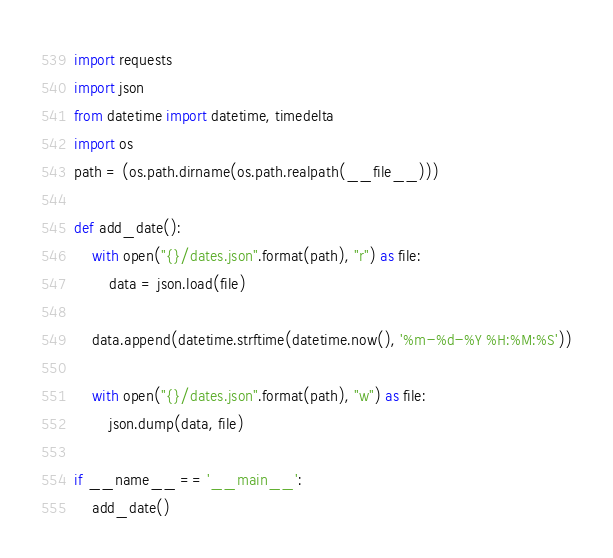<code> <loc_0><loc_0><loc_500><loc_500><_Python_>import requests
import json
from datetime import datetime, timedelta
import os
path = (os.path.dirname(os.path.realpath(__file__)))

def add_date():
    with open("{}/dates.json".format(path), "r") as file:
        data = json.load(file)

    data.append(datetime.strftime(datetime.now(), '%m-%d-%Y %H:%M:%S'))

    with open("{}/dates.json".format(path), "w") as file:
        json.dump(data, file)

if __name__ == '__main__':
    add_date()
</code> 